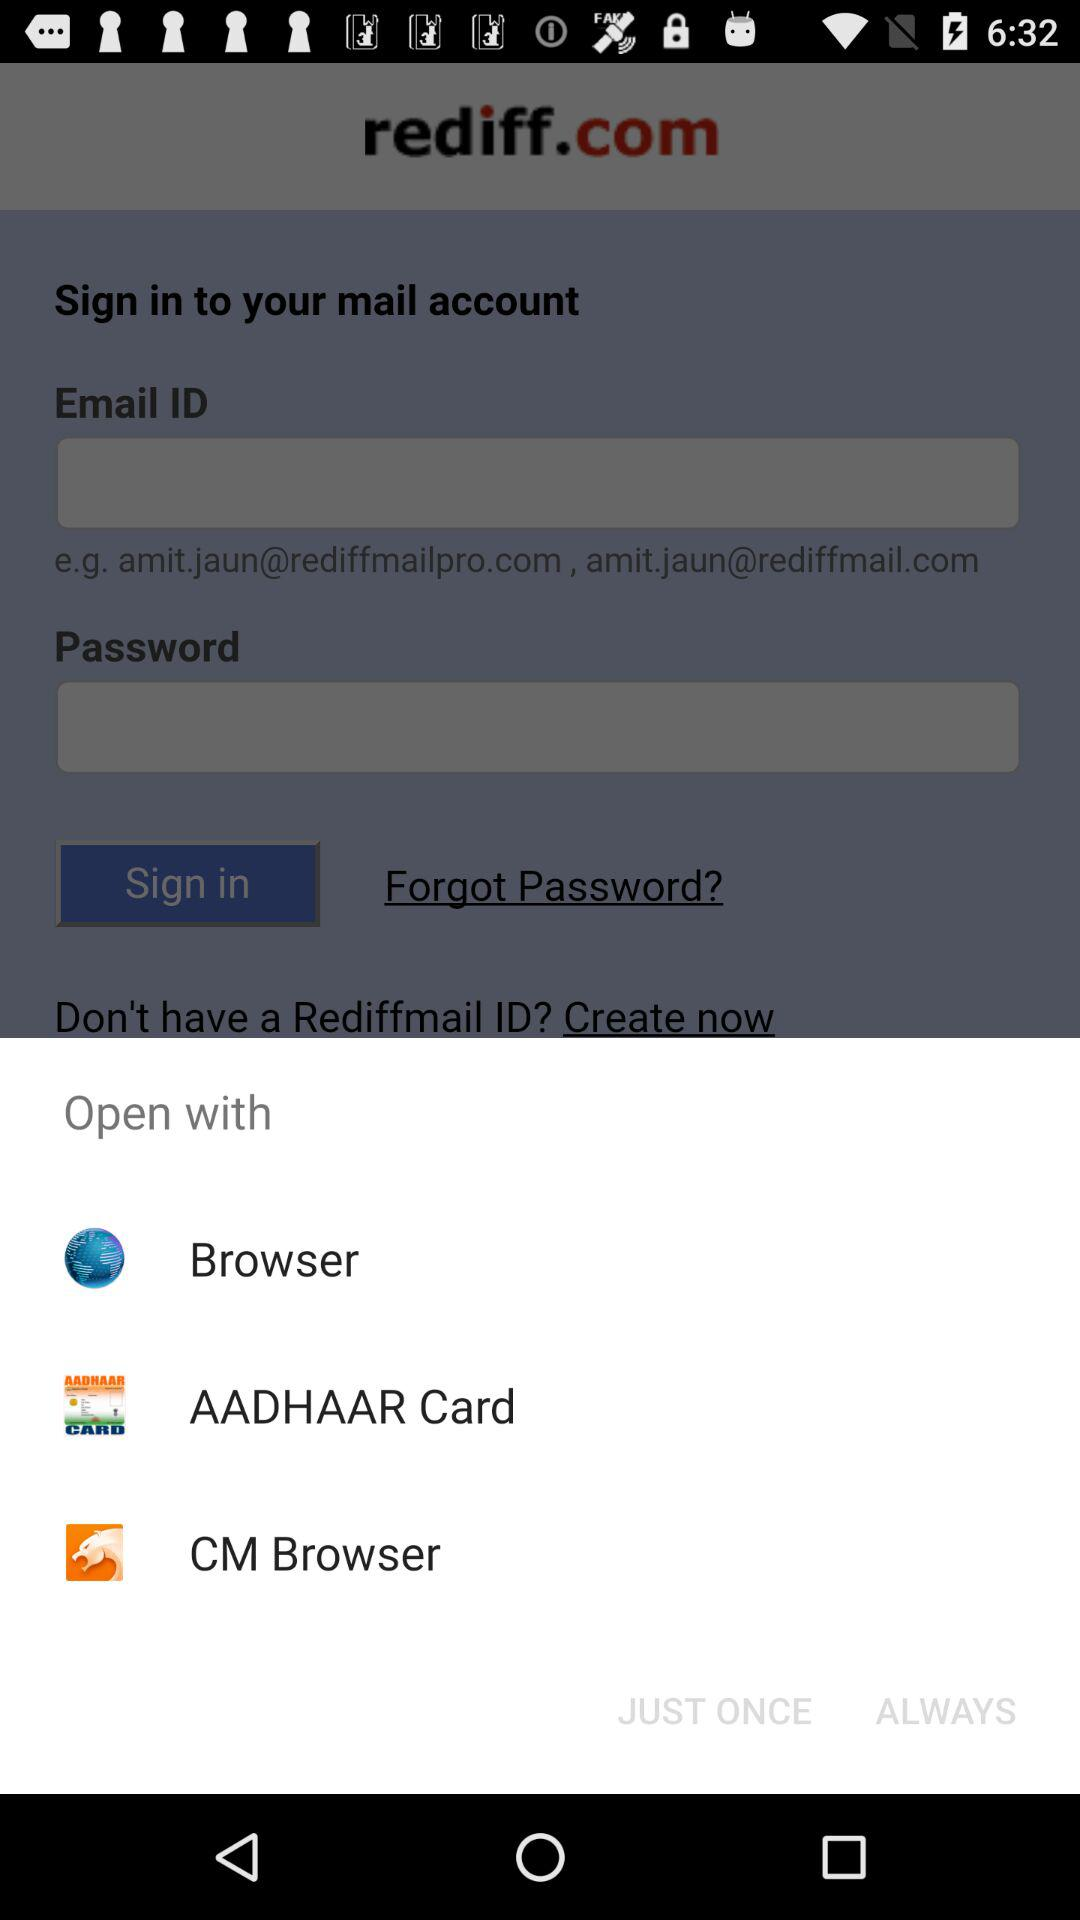How many open with options are there?
Answer the question using a single word or phrase. 3 